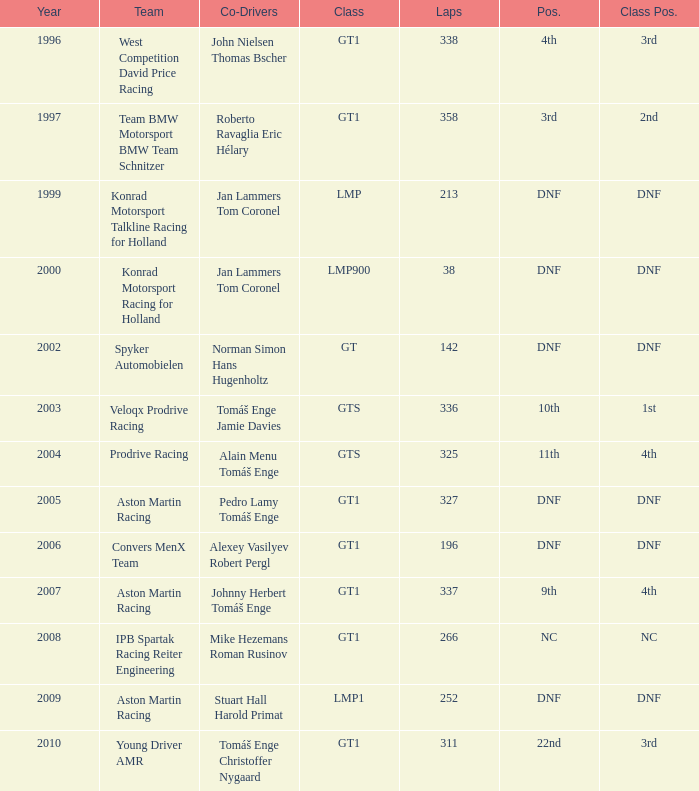Which position finished 3rd in class and completed less than 338 laps? 22nd. 